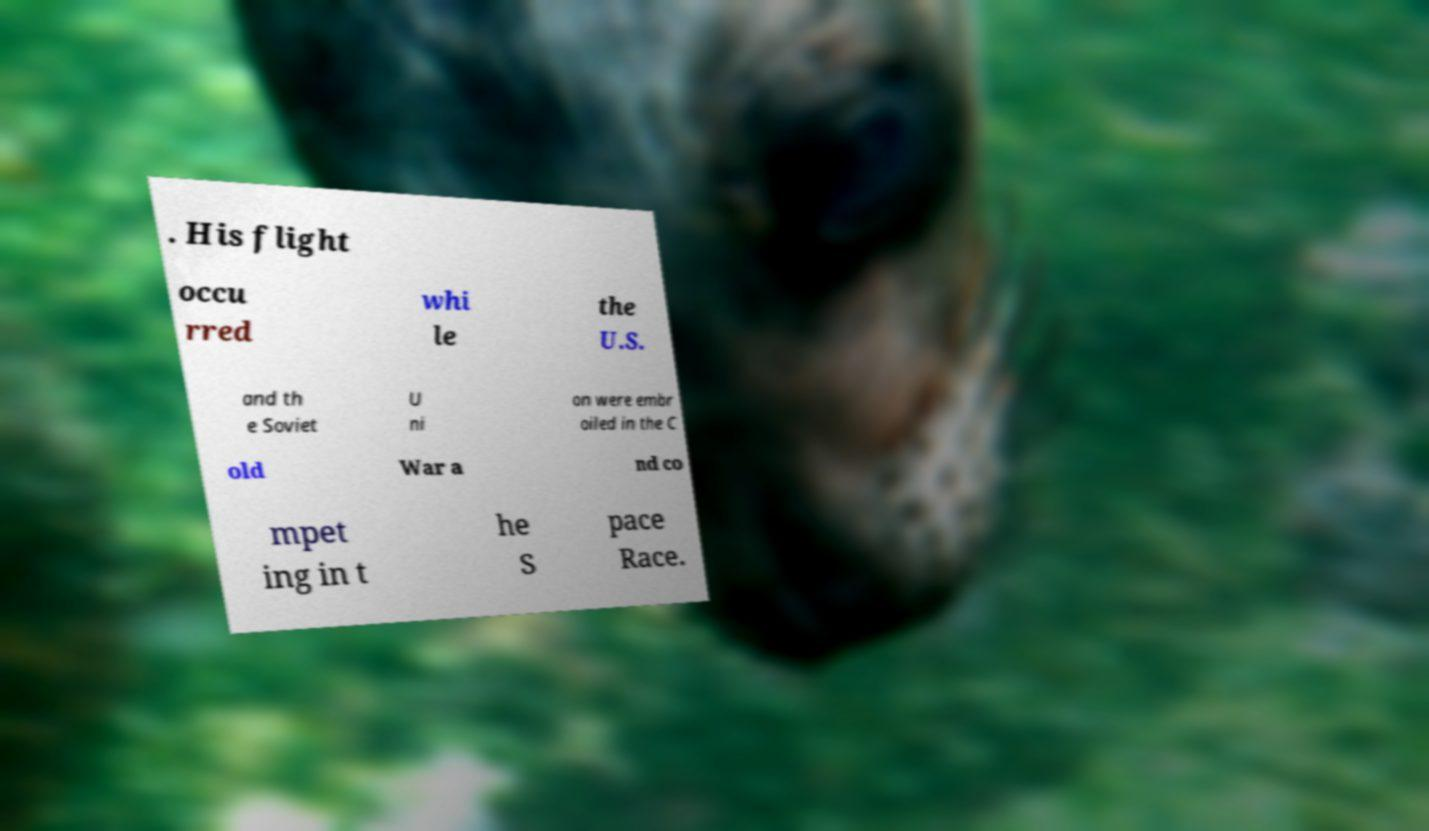Can you accurately transcribe the text from the provided image for me? . His flight occu rred whi le the U.S. and th e Soviet U ni on were embr oiled in the C old War a nd co mpet ing in t he S pace Race. 